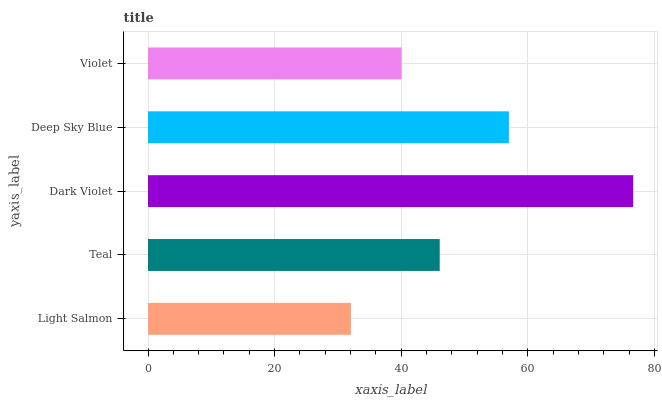Is Light Salmon the minimum?
Answer yes or no. Yes. Is Dark Violet the maximum?
Answer yes or no. Yes. Is Teal the minimum?
Answer yes or no. No. Is Teal the maximum?
Answer yes or no. No. Is Teal greater than Light Salmon?
Answer yes or no. Yes. Is Light Salmon less than Teal?
Answer yes or no. Yes. Is Light Salmon greater than Teal?
Answer yes or no. No. Is Teal less than Light Salmon?
Answer yes or no. No. Is Teal the high median?
Answer yes or no. Yes. Is Teal the low median?
Answer yes or no. Yes. Is Violet the high median?
Answer yes or no. No. Is Dark Violet the low median?
Answer yes or no. No. 